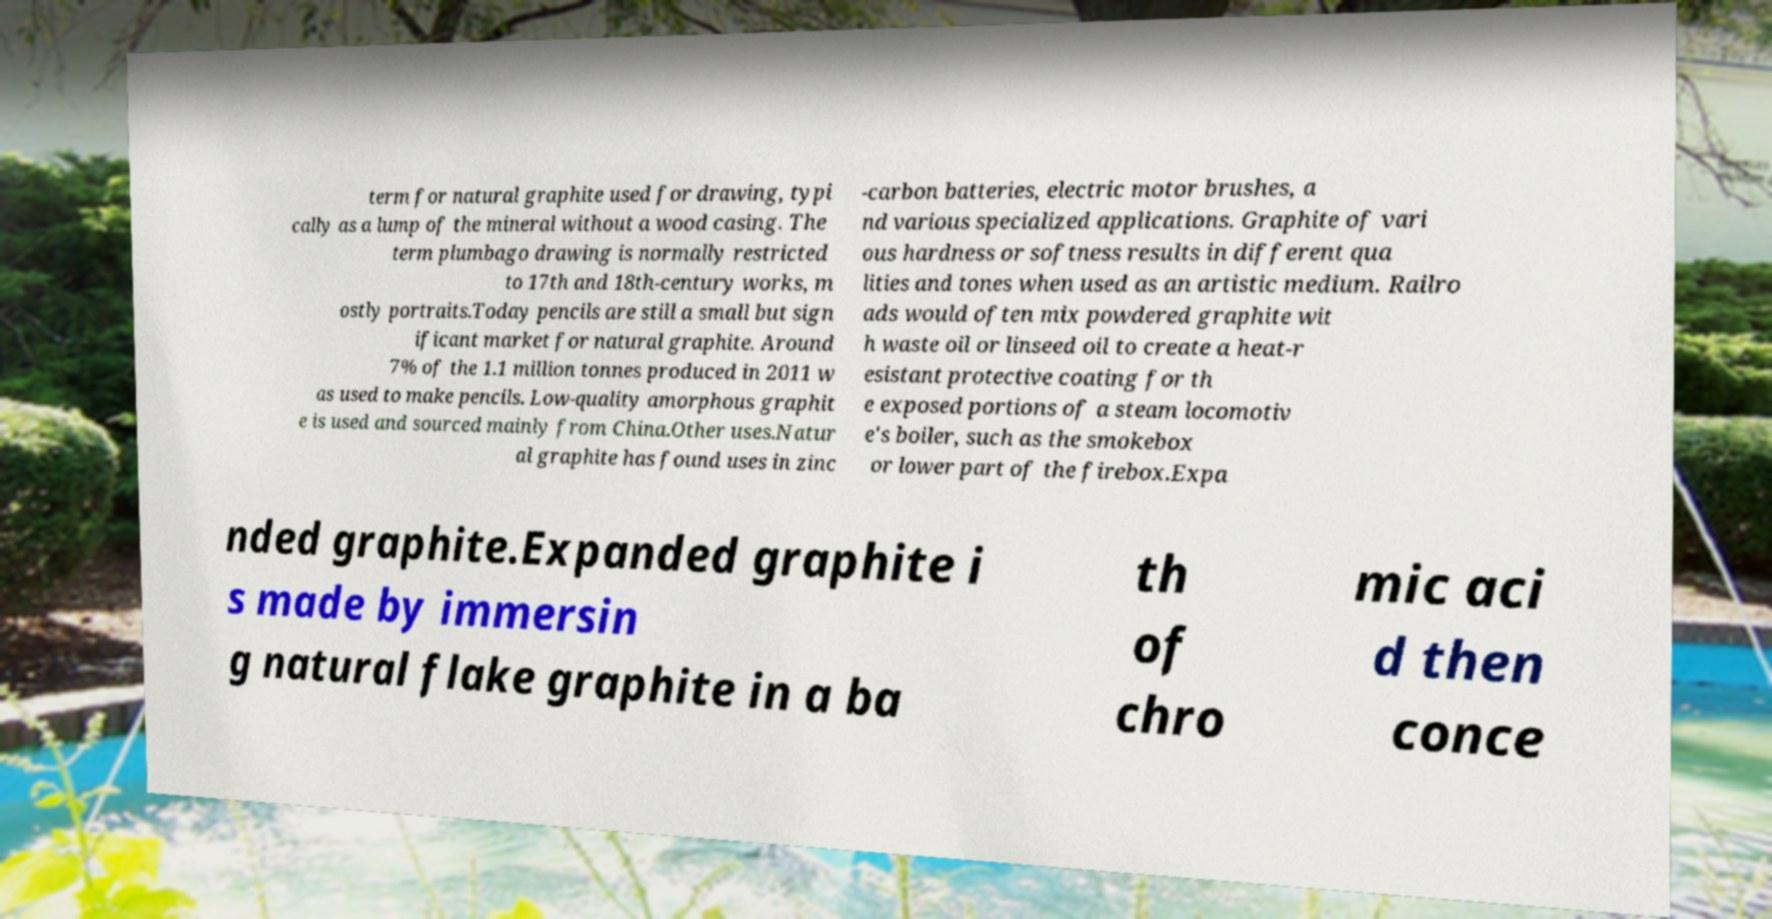Could you extract and type out the text from this image? term for natural graphite used for drawing, typi cally as a lump of the mineral without a wood casing. The term plumbago drawing is normally restricted to 17th and 18th-century works, m ostly portraits.Today pencils are still a small but sign ificant market for natural graphite. Around 7% of the 1.1 million tonnes produced in 2011 w as used to make pencils. Low-quality amorphous graphit e is used and sourced mainly from China.Other uses.Natur al graphite has found uses in zinc -carbon batteries, electric motor brushes, a nd various specialized applications. Graphite of vari ous hardness or softness results in different qua lities and tones when used as an artistic medium. Railro ads would often mix powdered graphite wit h waste oil or linseed oil to create a heat-r esistant protective coating for th e exposed portions of a steam locomotiv e's boiler, such as the smokebox or lower part of the firebox.Expa nded graphite.Expanded graphite i s made by immersin g natural flake graphite in a ba th of chro mic aci d then conce 